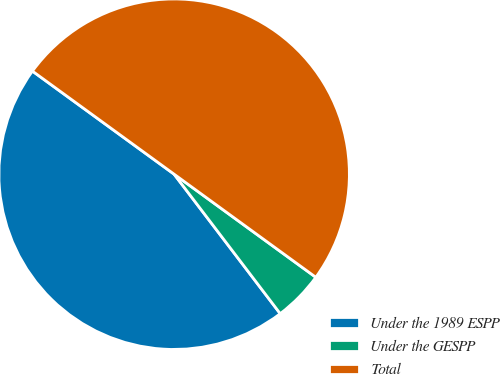<chart> <loc_0><loc_0><loc_500><loc_500><pie_chart><fcel>Under the 1989 ESPP<fcel>Under the GESPP<fcel>Total<nl><fcel>45.36%<fcel>4.64%<fcel>50.0%<nl></chart> 